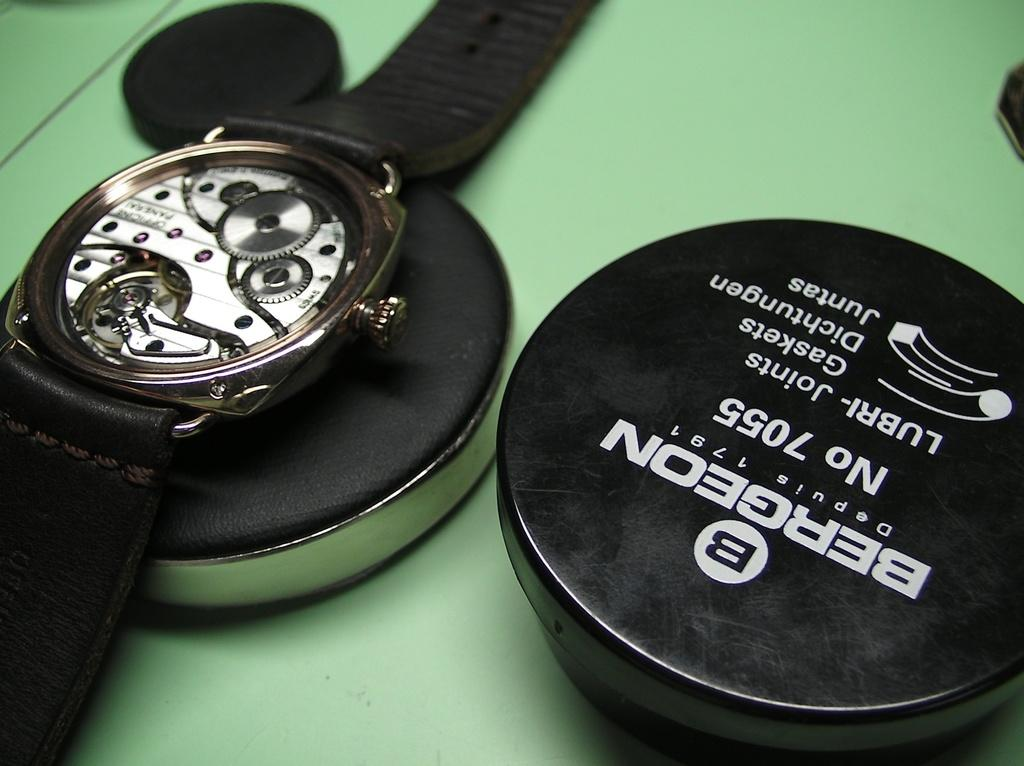<image>
Offer a succinct explanation of the picture presented. The round black container to the right of the watch contains Bergeon No 7705. 